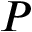<formula> <loc_0><loc_0><loc_500><loc_500>P</formula> 